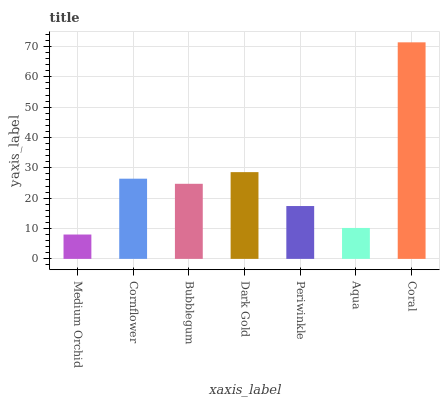Is Cornflower the minimum?
Answer yes or no. No. Is Cornflower the maximum?
Answer yes or no. No. Is Cornflower greater than Medium Orchid?
Answer yes or no. Yes. Is Medium Orchid less than Cornflower?
Answer yes or no. Yes. Is Medium Orchid greater than Cornflower?
Answer yes or no. No. Is Cornflower less than Medium Orchid?
Answer yes or no. No. Is Bubblegum the high median?
Answer yes or no. Yes. Is Bubblegum the low median?
Answer yes or no. Yes. Is Coral the high median?
Answer yes or no. No. Is Coral the low median?
Answer yes or no. No. 